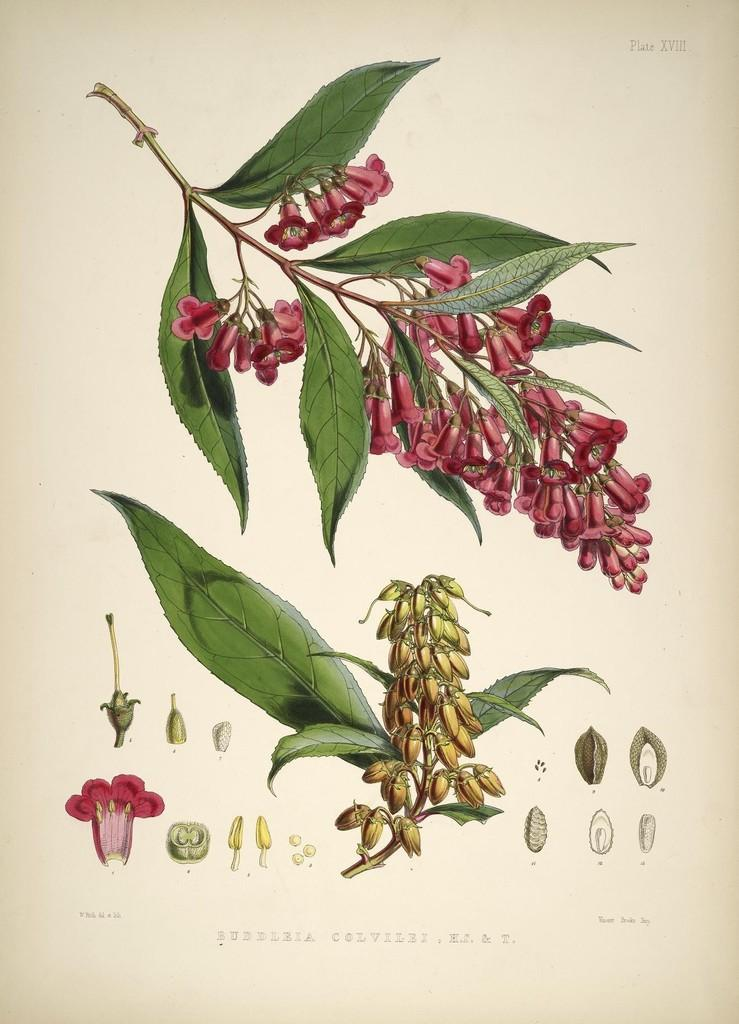What type of visual is depicted in the image? The image is a poster. What natural elements can be seen in the poster? There are flowers and leaves in the image. Is there any text present in the poster? Yes, there is text at the bottom of the image. What is the copper kettle used for in the image? There is no copper kettle present in the image. 